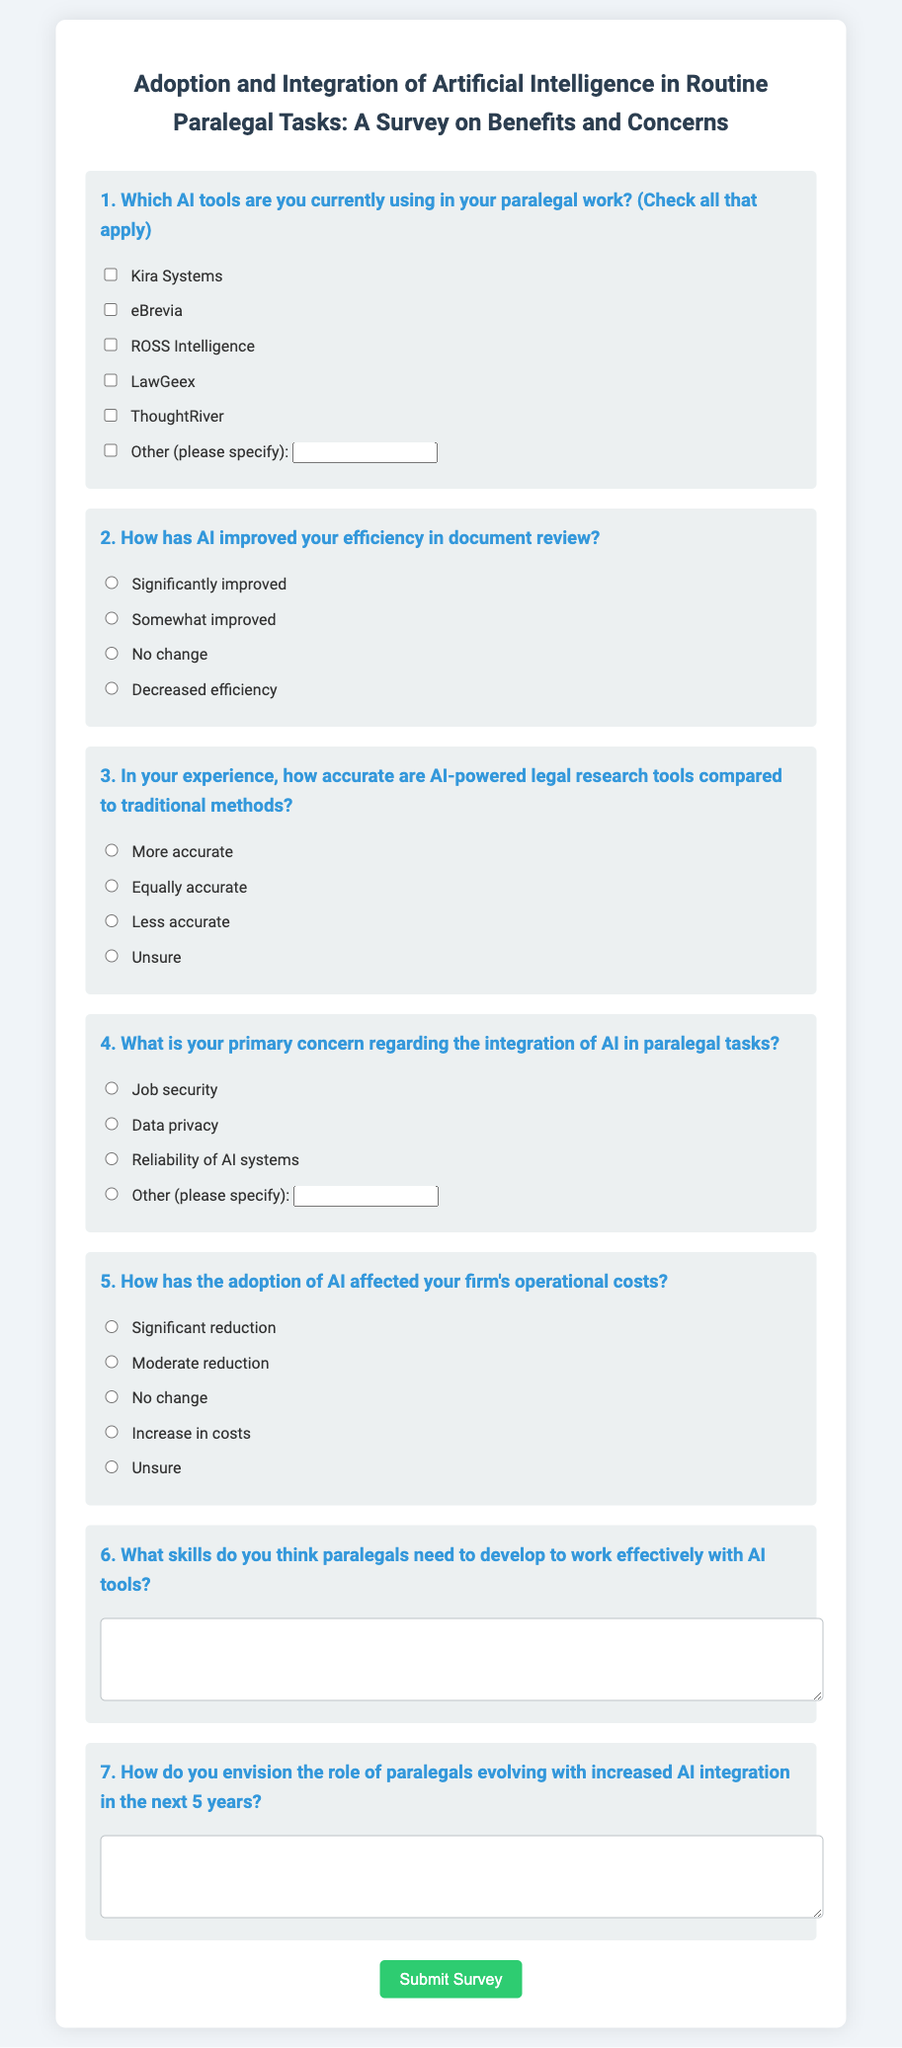What is the title of the survey? The title of the survey is the main heading, which outlines the focus on AI integration in paralegal tasks.
Answer: Adoption and Integration of Artificial Intelligence in Routine Paralegal Tasks: A Survey on Benefits and Concerns How many AI tools can the respondents select? The question allows respondents to check all that apply, which indicates that there is no fixed limit to the number of tools they can select.
Answer: Multiple What concern is specifically listed regarding AI integration? The document presents several options for respondents' primary concern, including job security and data privacy.
Answer: Job security What type of skills does the questionnaire ask respondents to identify? The question requests insights on which skills are essential for paralegals to work effectively with AI tools.
Answer: Skills for working with AI tools What is the format for the skills and future role questions? The document includes questions that require respondents to provide longer textual responses instead of selecting from options, thus emphasizing elaboration.
Answer: Text area What is the color of the submit button in the survey form? The design details of the button, which highlights its action orientation, describe its appearance and intent within the context.
Answer: Green 